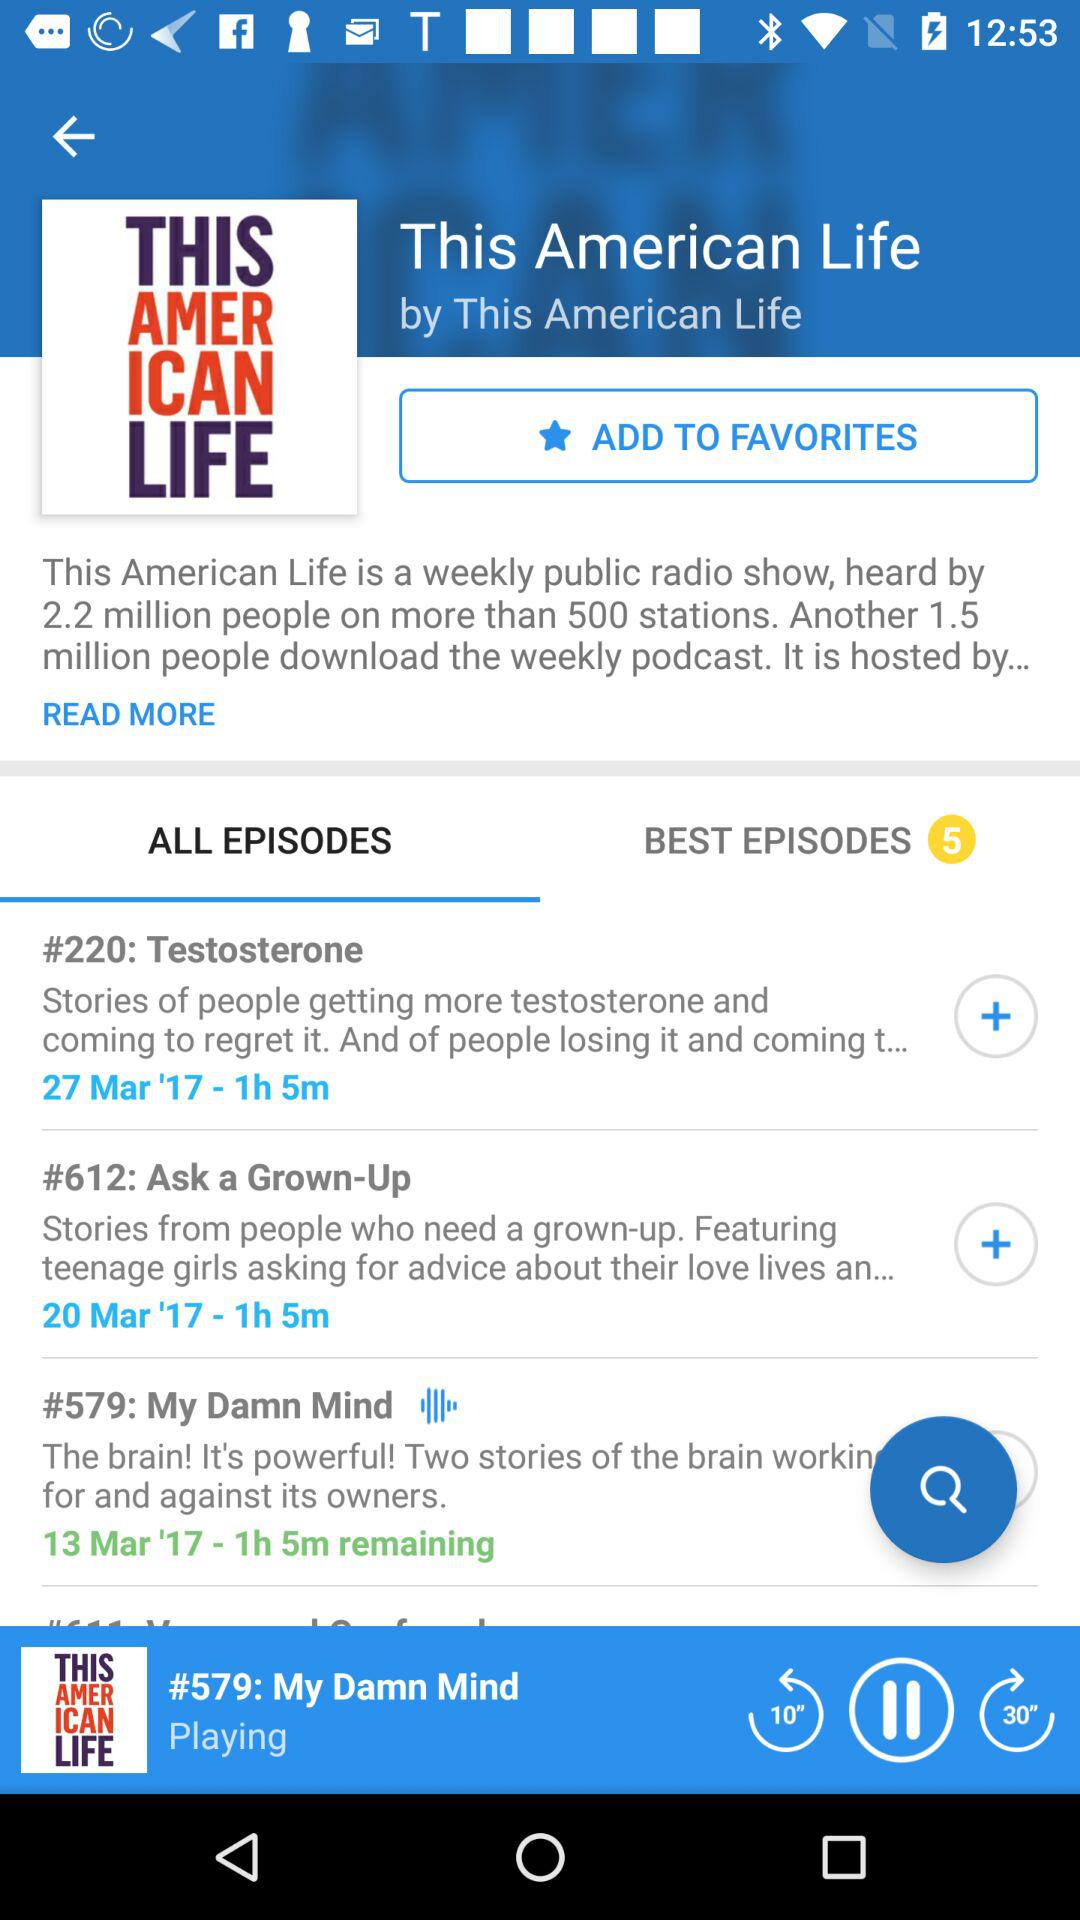Which tab is selected? The selected tab is "ALL EPISODES". 